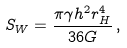Convert formula to latex. <formula><loc_0><loc_0><loc_500><loc_500>S _ { W } = \frac { \pi \gamma h ^ { 2 } r _ { H } ^ { 4 } } { 3 6 G } \, ,</formula> 